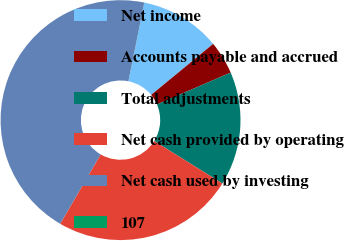Convert chart. <chart><loc_0><loc_0><loc_500><loc_500><pie_chart><fcel>Net income<fcel>Accounts payable and accrued<fcel>Total adjustments<fcel>Net cash provided by operating<fcel>Net cash used by investing<fcel>107<nl><fcel>10.86%<fcel>4.48%<fcel>15.34%<fcel>24.53%<fcel>44.79%<fcel>0.01%<nl></chart> 